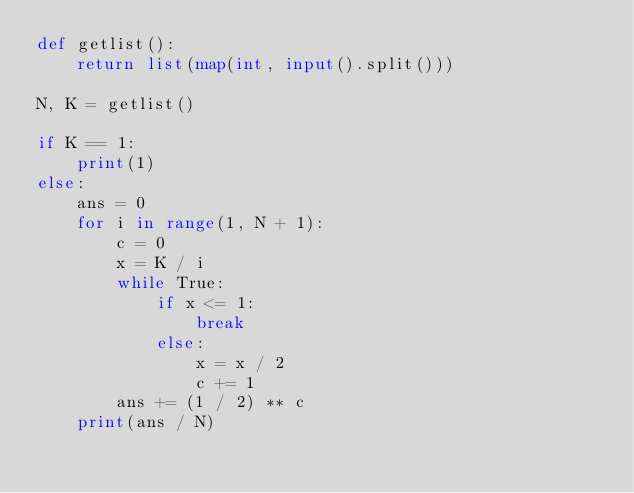Convert code to text. <code><loc_0><loc_0><loc_500><loc_500><_Python_>def getlist():
	return list(map(int, input().split()))

N, K = getlist()

if K == 1:
	print(1)
else:
	ans = 0
	for i in range(1, N + 1):
		c = 0
		x = K / i
		while True:
			if x <= 1:
				break
			else:
				x = x / 2
				c += 1
		ans += (1 / 2) ** c
	print(ans / N)</code> 